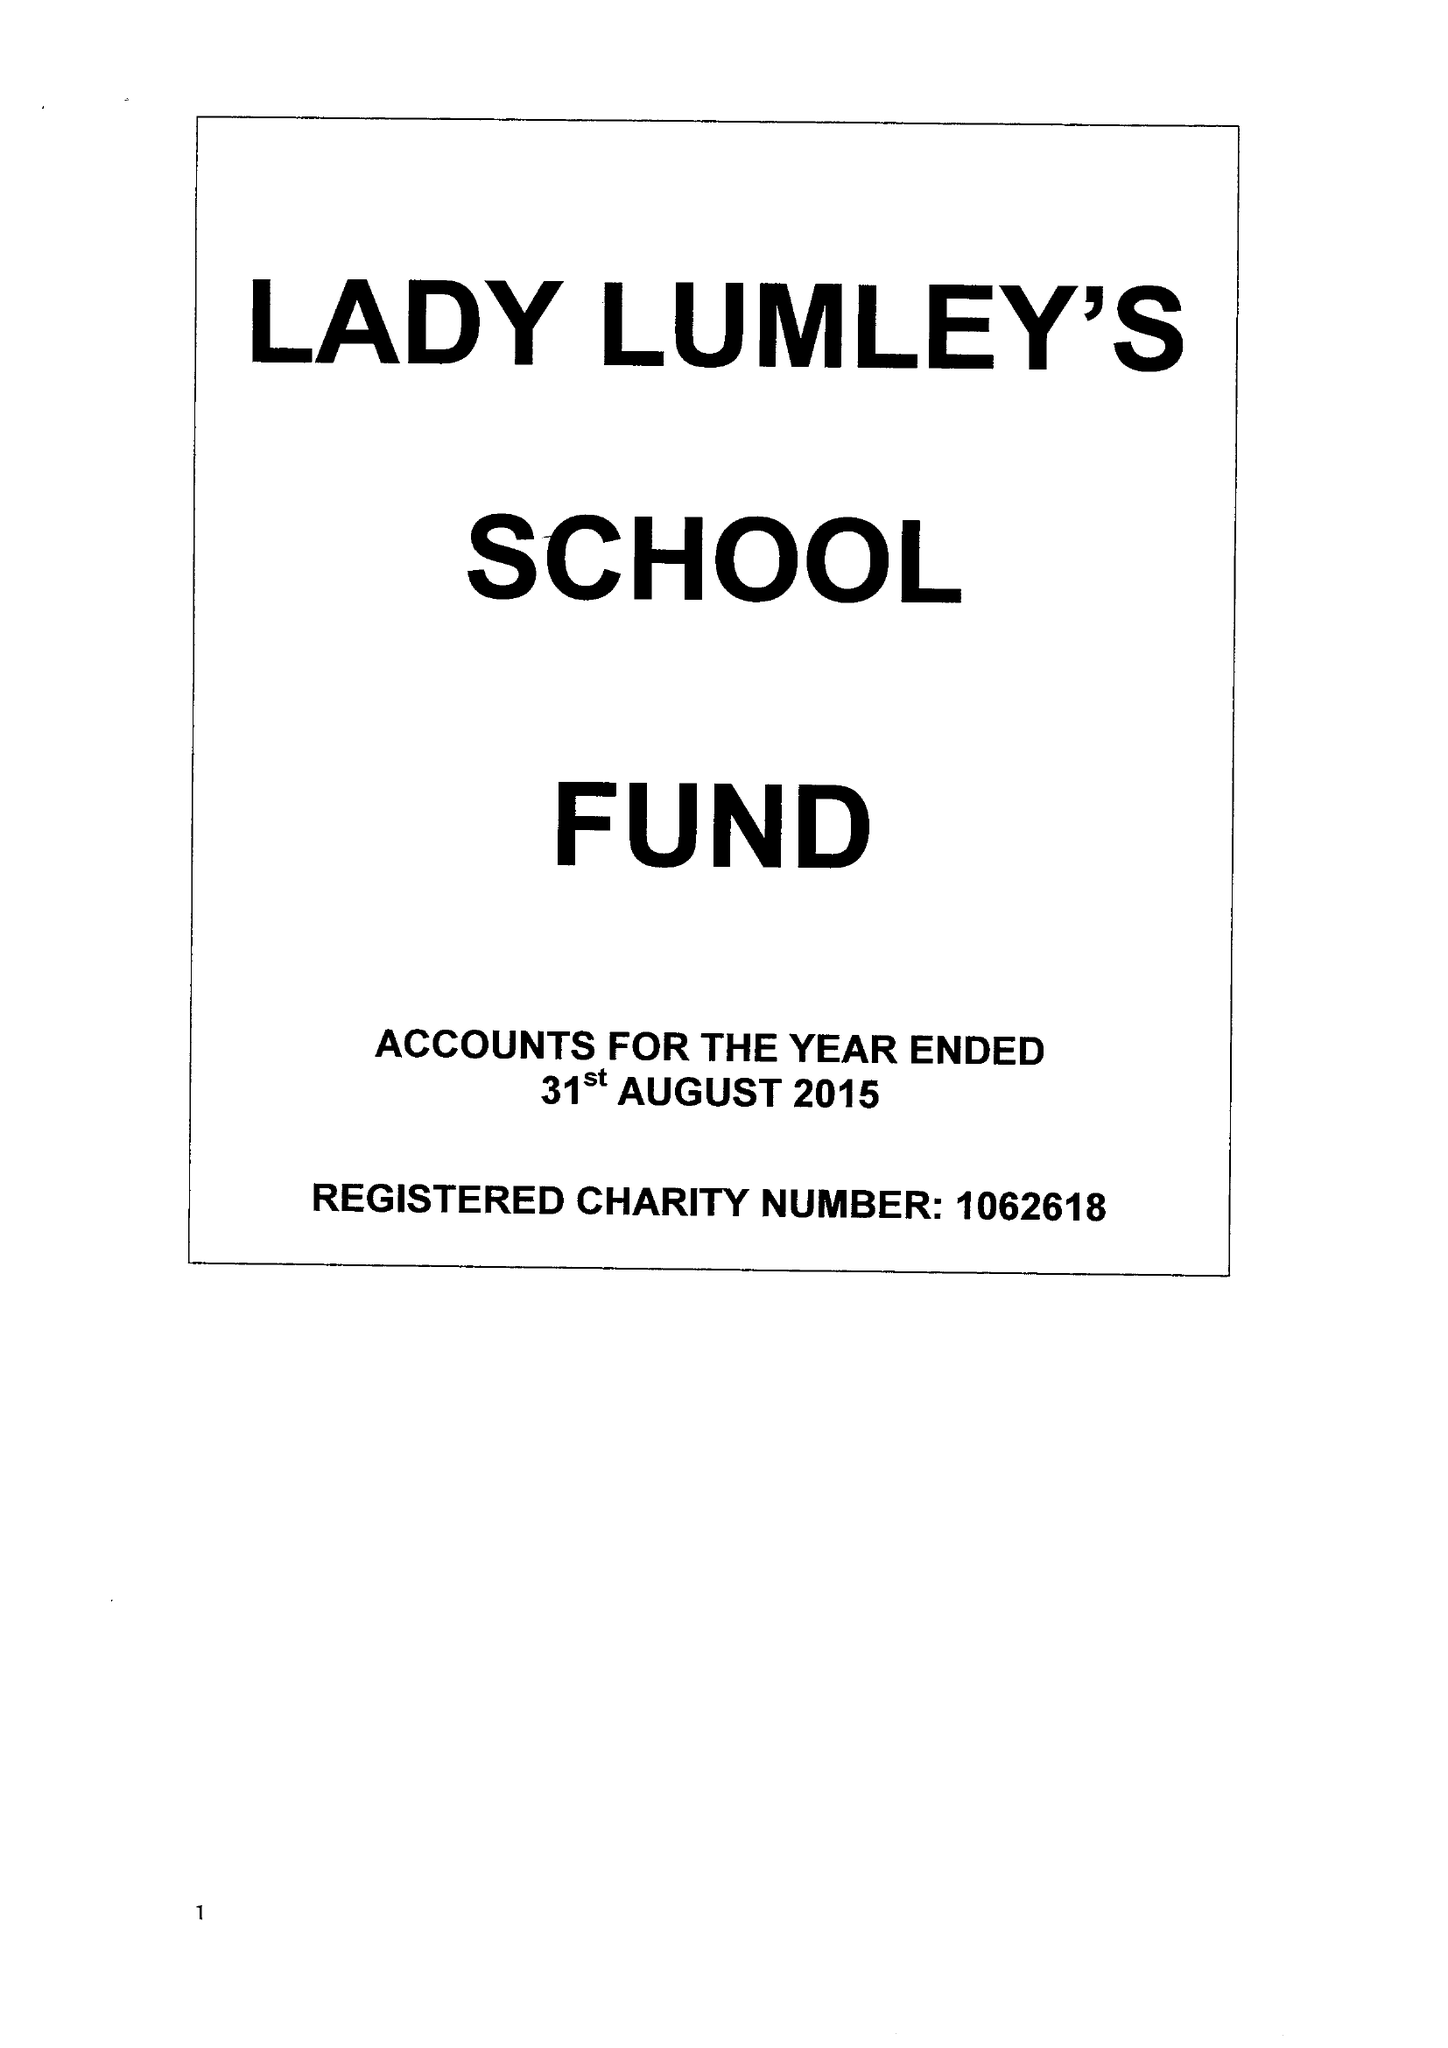What is the value for the charity_number?
Answer the question using a single word or phrase. 1062618 